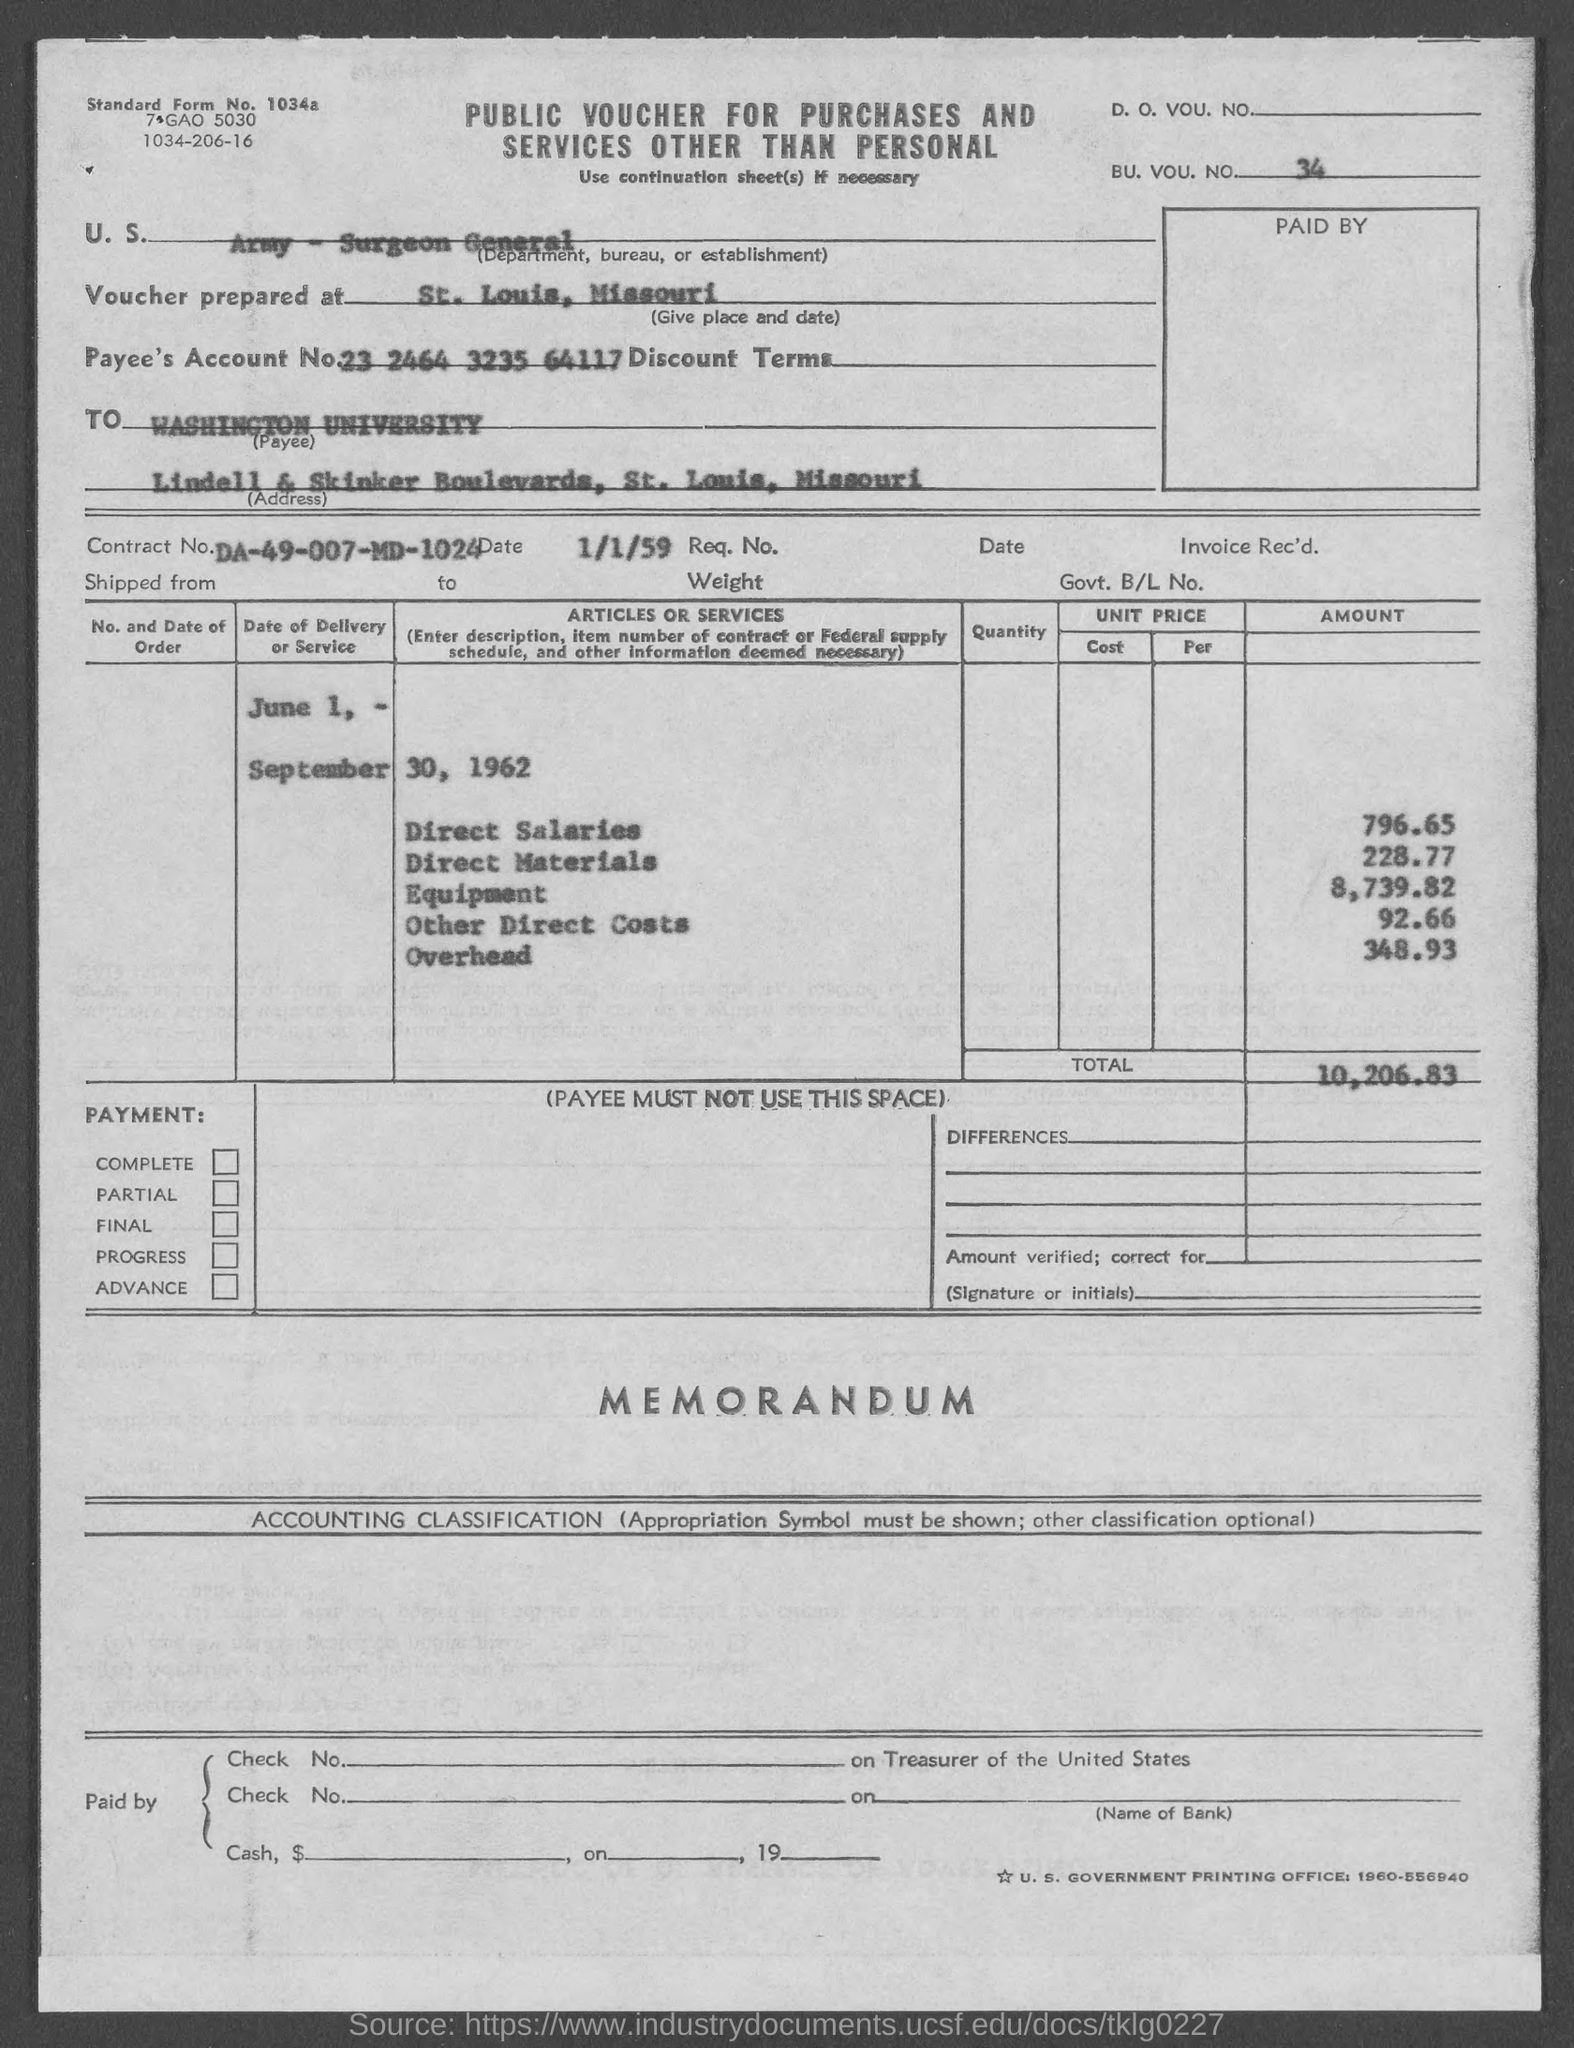List a handful of essential elements in this visual. The other direct costs are 92.66... The direct material amount is $228.77. What is the number 34? Washington University is located in St. Louis County. The direct salaries amount is $796.65. 